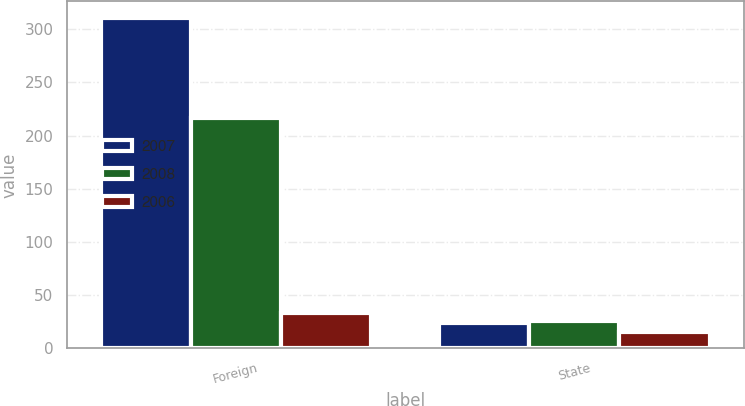Convert chart to OTSL. <chart><loc_0><loc_0><loc_500><loc_500><stacked_bar_chart><ecel><fcel>Foreign<fcel>State<nl><fcel>2007<fcel>310.6<fcel>24.3<nl><fcel>2008<fcel>216.7<fcel>25.8<nl><fcel>2006<fcel>33<fcel>15.8<nl></chart> 